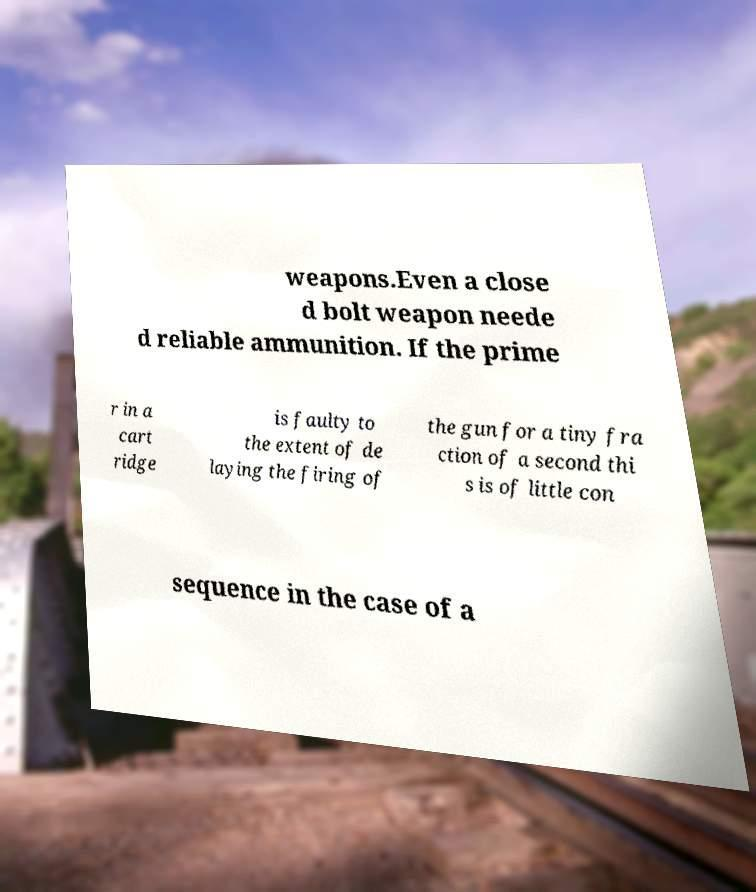I need the written content from this picture converted into text. Can you do that? weapons.Even a close d bolt weapon neede d reliable ammunition. If the prime r in a cart ridge is faulty to the extent of de laying the firing of the gun for a tiny fra ction of a second thi s is of little con sequence in the case of a 